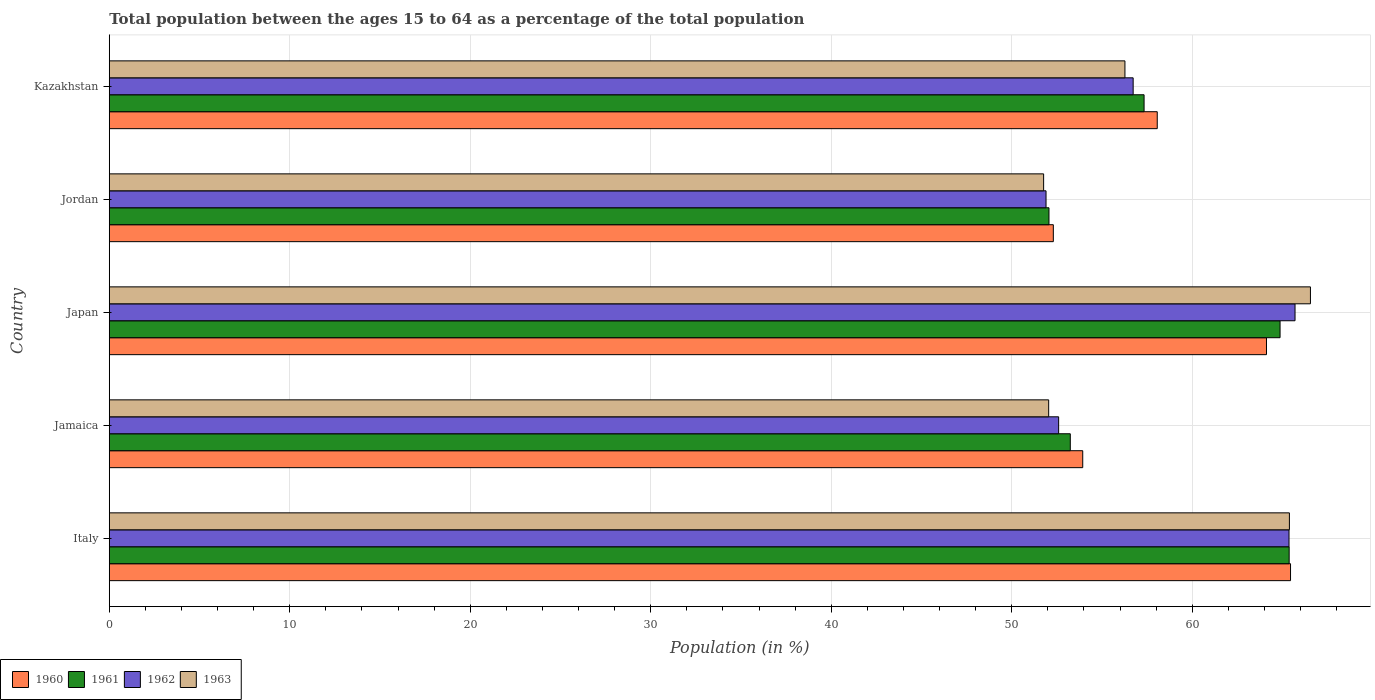Are the number of bars per tick equal to the number of legend labels?
Your answer should be very brief. Yes. Are the number of bars on each tick of the Y-axis equal?
Provide a succinct answer. Yes. How many bars are there on the 2nd tick from the top?
Keep it short and to the point. 4. What is the label of the 4th group of bars from the top?
Offer a terse response. Jamaica. In how many cases, is the number of bars for a given country not equal to the number of legend labels?
Provide a succinct answer. 0. What is the percentage of the population ages 15 to 64 in 1961 in Italy?
Keep it short and to the point. 65.37. Across all countries, what is the maximum percentage of the population ages 15 to 64 in 1963?
Your answer should be very brief. 66.55. Across all countries, what is the minimum percentage of the population ages 15 to 64 in 1962?
Keep it short and to the point. 51.9. In which country was the percentage of the population ages 15 to 64 in 1963 maximum?
Ensure brevity in your answer.  Japan. In which country was the percentage of the population ages 15 to 64 in 1961 minimum?
Your answer should be very brief. Jordan. What is the total percentage of the population ages 15 to 64 in 1962 in the graph?
Your answer should be compact. 292.29. What is the difference between the percentage of the population ages 15 to 64 in 1962 in Japan and that in Jordan?
Make the answer very short. 13.8. What is the difference between the percentage of the population ages 15 to 64 in 1961 in Jordan and the percentage of the population ages 15 to 64 in 1960 in Italy?
Offer a terse response. -13.38. What is the average percentage of the population ages 15 to 64 in 1963 per country?
Offer a very short reply. 58.4. What is the difference between the percentage of the population ages 15 to 64 in 1960 and percentage of the population ages 15 to 64 in 1963 in Japan?
Offer a very short reply. -2.43. In how many countries, is the percentage of the population ages 15 to 64 in 1962 greater than 8 ?
Provide a succinct answer. 5. What is the ratio of the percentage of the population ages 15 to 64 in 1961 in Jamaica to that in Jordan?
Your answer should be very brief. 1.02. What is the difference between the highest and the second highest percentage of the population ages 15 to 64 in 1963?
Keep it short and to the point. 1.17. What is the difference between the highest and the lowest percentage of the population ages 15 to 64 in 1963?
Provide a short and direct response. 14.78. In how many countries, is the percentage of the population ages 15 to 64 in 1963 greater than the average percentage of the population ages 15 to 64 in 1963 taken over all countries?
Give a very brief answer. 2. Is the sum of the percentage of the population ages 15 to 64 in 1962 in Italy and Jamaica greater than the maximum percentage of the population ages 15 to 64 in 1961 across all countries?
Provide a short and direct response. Yes. Is it the case that in every country, the sum of the percentage of the population ages 15 to 64 in 1961 and percentage of the population ages 15 to 64 in 1962 is greater than the percentage of the population ages 15 to 64 in 1963?
Offer a terse response. Yes. Are all the bars in the graph horizontal?
Your answer should be very brief. Yes. How many countries are there in the graph?
Keep it short and to the point. 5. What is the difference between two consecutive major ticks on the X-axis?
Give a very brief answer. 10. Does the graph contain any zero values?
Make the answer very short. No. How many legend labels are there?
Offer a very short reply. 4. How are the legend labels stacked?
Give a very brief answer. Horizontal. What is the title of the graph?
Keep it short and to the point. Total population between the ages 15 to 64 as a percentage of the total population. Does "1984" appear as one of the legend labels in the graph?
Your answer should be compact. No. What is the label or title of the Y-axis?
Give a very brief answer. Country. What is the Population (in %) of 1960 in Italy?
Ensure brevity in your answer.  65.45. What is the Population (in %) in 1961 in Italy?
Your answer should be compact. 65.37. What is the Population (in %) of 1962 in Italy?
Make the answer very short. 65.36. What is the Population (in %) in 1963 in Italy?
Provide a short and direct response. 65.38. What is the Population (in %) of 1960 in Jamaica?
Provide a short and direct response. 53.93. What is the Population (in %) of 1961 in Jamaica?
Provide a succinct answer. 53.25. What is the Population (in %) in 1962 in Jamaica?
Your answer should be compact. 52.6. What is the Population (in %) in 1963 in Jamaica?
Provide a succinct answer. 52.05. What is the Population (in %) in 1960 in Japan?
Your answer should be compact. 64.11. What is the Population (in %) in 1961 in Japan?
Your answer should be compact. 64.87. What is the Population (in %) in 1962 in Japan?
Your answer should be compact. 65.7. What is the Population (in %) of 1963 in Japan?
Provide a short and direct response. 66.55. What is the Population (in %) of 1960 in Jordan?
Your answer should be very brief. 52.31. What is the Population (in %) of 1961 in Jordan?
Your answer should be compact. 52.06. What is the Population (in %) in 1962 in Jordan?
Give a very brief answer. 51.9. What is the Population (in %) in 1963 in Jordan?
Your answer should be compact. 51.77. What is the Population (in %) of 1960 in Kazakhstan?
Your answer should be compact. 58.06. What is the Population (in %) of 1961 in Kazakhstan?
Ensure brevity in your answer.  57.33. What is the Population (in %) in 1962 in Kazakhstan?
Provide a succinct answer. 56.73. What is the Population (in %) of 1963 in Kazakhstan?
Provide a succinct answer. 56.27. Across all countries, what is the maximum Population (in %) of 1960?
Make the answer very short. 65.45. Across all countries, what is the maximum Population (in %) of 1961?
Provide a succinct answer. 65.37. Across all countries, what is the maximum Population (in %) in 1962?
Offer a very short reply. 65.7. Across all countries, what is the maximum Population (in %) of 1963?
Offer a very short reply. 66.55. Across all countries, what is the minimum Population (in %) of 1960?
Keep it short and to the point. 52.31. Across all countries, what is the minimum Population (in %) of 1961?
Your answer should be very brief. 52.06. Across all countries, what is the minimum Population (in %) of 1962?
Make the answer very short. 51.9. Across all countries, what is the minimum Population (in %) in 1963?
Ensure brevity in your answer.  51.77. What is the total Population (in %) in 1960 in the graph?
Make the answer very short. 293.86. What is the total Population (in %) in 1961 in the graph?
Ensure brevity in your answer.  292.88. What is the total Population (in %) of 1962 in the graph?
Ensure brevity in your answer.  292.29. What is the total Population (in %) in 1963 in the graph?
Provide a succinct answer. 292.02. What is the difference between the Population (in %) of 1960 in Italy and that in Jamaica?
Your answer should be very brief. 11.51. What is the difference between the Population (in %) in 1961 in Italy and that in Jamaica?
Give a very brief answer. 12.13. What is the difference between the Population (in %) of 1962 in Italy and that in Jamaica?
Your response must be concise. 12.76. What is the difference between the Population (in %) in 1963 in Italy and that in Jamaica?
Your answer should be compact. 13.34. What is the difference between the Population (in %) of 1960 in Italy and that in Japan?
Your response must be concise. 1.33. What is the difference between the Population (in %) of 1961 in Italy and that in Japan?
Your answer should be very brief. 0.5. What is the difference between the Population (in %) of 1962 in Italy and that in Japan?
Your answer should be very brief. -0.33. What is the difference between the Population (in %) in 1963 in Italy and that in Japan?
Give a very brief answer. -1.17. What is the difference between the Population (in %) in 1960 in Italy and that in Jordan?
Your answer should be compact. 13.14. What is the difference between the Population (in %) in 1961 in Italy and that in Jordan?
Offer a terse response. 13.31. What is the difference between the Population (in %) in 1962 in Italy and that in Jordan?
Your answer should be compact. 13.46. What is the difference between the Population (in %) of 1963 in Italy and that in Jordan?
Your answer should be very brief. 13.62. What is the difference between the Population (in %) of 1960 in Italy and that in Kazakhstan?
Your answer should be compact. 7.38. What is the difference between the Population (in %) in 1961 in Italy and that in Kazakhstan?
Your answer should be very brief. 8.04. What is the difference between the Population (in %) of 1962 in Italy and that in Kazakhstan?
Give a very brief answer. 8.64. What is the difference between the Population (in %) of 1963 in Italy and that in Kazakhstan?
Ensure brevity in your answer.  9.11. What is the difference between the Population (in %) of 1960 in Jamaica and that in Japan?
Make the answer very short. -10.18. What is the difference between the Population (in %) of 1961 in Jamaica and that in Japan?
Keep it short and to the point. -11.62. What is the difference between the Population (in %) of 1962 in Jamaica and that in Japan?
Provide a succinct answer. -13.1. What is the difference between the Population (in %) of 1963 in Jamaica and that in Japan?
Your response must be concise. -14.5. What is the difference between the Population (in %) in 1960 in Jamaica and that in Jordan?
Offer a very short reply. 1.63. What is the difference between the Population (in %) of 1961 in Jamaica and that in Jordan?
Provide a succinct answer. 1.18. What is the difference between the Population (in %) in 1962 in Jamaica and that in Jordan?
Your answer should be very brief. 0.7. What is the difference between the Population (in %) of 1963 in Jamaica and that in Jordan?
Provide a short and direct response. 0.28. What is the difference between the Population (in %) of 1960 in Jamaica and that in Kazakhstan?
Keep it short and to the point. -4.13. What is the difference between the Population (in %) of 1961 in Jamaica and that in Kazakhstan?
Your response must be concise. -4.09. What is the difference between the Population (in %) in 1962 in Jamaica and that in Kazakhstan?
Your answer should be compact. -4.13. What is the difference between the Population (in %) in 1963 in Jamaica and that in Kazakhstan?
Make the answer very short. -4.23. What is the difference between the Population (in %) of 1960 in Japan and that in Jordan?
Make the answer very short. 11.81. What is the difference between the Population (in %) in 1961 in Japan and that in Jordan?
Provide a short and direct response. 12.8. What is the difference between the Population (in %) in 1962 in Japan and that in Jordan?
Offer a terse response. 13.8. What is the difference between the Population (in %) in 1963 in Japan and that in Jordan?
Ensure brevity in your answer.  14.78. What is the difference between the Population (in %) in 1960 in Japan and that in Kazakhstan?
Offer a very short reply. 6.05. What is the difference between the Population (in %) of 1961 in Japan and that in Kazakhstan?
Your answer should be compact. 7.53. What is the difference between the Population (in %) of 1962 in Japan and that in Kazakhstan?
Keep it short and to the point. 8.97. What is the difference between the Population (in %) in 1963 in Japan and that in Kazakhstan?
Ensure brevity in your answer.  10.28. What is the difference between the Population (in %) of 1960 in Jordan and that in Kazakhstan?
Make the answer very short. -5.76. What is the difference between the Population (in %) of 1961 in Jordan and that in Kazakhstan?
Ensure brevity in your answer.  -5.27. What is the difference between the Population (in %) of 1962 in Jordan and that in Kazakhstan?
Offer a terse response. -4.83. What is the difference between the Population (in %) of 1963 in Jordan and that in Kazakhstan?
Your answer should be compact. -4.51. What is the difference between the Population (in %) of 1960 in Italy and the Population (in %) of 1961 in Jamaica?
Give a very brief answer. 12.2. What is the difference between the Population (in %) in 1960 in Italy and the Population (in %) in 1962 in Jamaica?
Ensure brevity in your answer.  12.85. What is the difference between the Population (in %) of 1960 in Italy and the Population (in %) of 1963 in Jamaica?
Make the answer very short. 13.4. What is the difference between the Population (in %) of 1961 in Italy and the Population (in %) of 1962 in Jamaica?
Your answer should be compact. 12.77. What is the difference between the Population (in %) in 1961 in Italy and the Population (in %) in 1963 in Jamaica?
Offer a terse response. 13.32. What is the difference between the Population (in %) of 1962 in Italy and the Population (in %) of 1963 in Jamaica?
Give a very brief answer. 13.32. What is the difference between the Population (in %) of 1960 in Italy and the Population (in %) of 1961 in Japan?
Provide a succinct answer. 0.58. What is the difference between the Population (in %) in 1960 in Italy and the Population (in %) in 1962 in Japan?
Offer a terse response. -0.25. What is the difference between the Population (in %) in 1960 in Italy and the Population (in %) in 1963 in Japan?
Your answer should be very brief. -1.1. What is the difference between the Population (in %) of 1961 in Italy and the Population (in %) of 1962 in Japan?
Offer a very short reply. -0.33. What is the difference between the Population (in %) in 1961 in Italy and the Population (in %) in 1963 in Japan?
Ensure brevity in your answer.  -1.18. What is the difference between the Population (in %) in 1962 in Italy and the Population (in %) in 1963 in Japan?
Provide a short and direct response. -1.19. What is the difference between the Population (in %) of 1960 in Italy and the Population (in %) of 1961 in Jordan?
Keep it short and to the point. 13.38. What is the difference between the Population (in %) in 1960 in Italy and the Population (in %) in 1962 in Jordan?
Keep it short and to the point. 13.55. What is the difference between the Population (in %) in 1960 in Italy and the Population (in %) in 1963 in Jordan?
Give a very brief answer. 13.68. What is the difference between the Population (in %) in 1961 in Italy and the Population (in %) in 1962 in Jordan?
Your response must be concise. 13.47. What is the difference between the Population (in %) in 1961 in Italy and the Population (in %) in 1963 in Jordan?
Keep it short and to the point. 13.6. What is the difference between the Population (in %) in 1962 in Italy and the Population (in %) in 1963 in Jordan?
Provide a short and direct response. 13.6. What is the difference between the Population (in %) of 1960 in Italy and the Population (in %) of 1961 in Kazakhstan?
Make the answer very short. 8.11. What is the difference between the Population (in %) in 1960 in Italy and the Population (in %) in 1962 in Kazakhstan?
Ensure brevity in your answer.  8.72. What is the difference between the Population (in %) of 1960 in Italy and the Population (in %) of 1963 in Kazakhstan?
Make the answer very short. 9.17. What is the difference between the Population (in %) in 1961 in Italy and the Population (in %) in 1962 in Kazakhstan?
Offer a terse response. 8.64. What is the difference between the Population (in %) of 1961 in Italy and the Population (in %) of 1963 in Kazakhstan?
Keep it short and to the point. 9.1. What is the difference between the Population (in %) in 1962 in Italy and the Population (in %) in 1963 in Kazakhstan?
Your response must be concise. 9.09. What is the difference between the Population (in %) of 1960 in Jamaica and the Population (in %) of 1961 in Japan?
Offer a terse response. -10.93. What is the difference between the Population (in %) in 1960 in Jamaica and the Population (in %) in 1962 in Japan?
Keep it short and to the point. -11.76. What is the difference between the Population (in %) of 1960 in Jamaica and the Population (in %) of 1963 in Japan?
Ensure brevity in your answer.  -12.62. What is the difference between the Population (in %) of 1961 in Jamaica and the Population (in %) of 1962 in Japan?
Provide a succinct answer. -12.45. What is the difference between the Population (in %) in 1961 in Jamaica and the Population (in %) in 1963 in Japan?
Your response must be concise. -13.3. What is the difference between the Population (in %) in 1962 in Jamaica and the Population (in %) in 1963 in Japan?
Offer a very short reply. -13.95. What is the difference between the Population (in %) in 1960 in Jamaica and the Population (in %) in 1961 in Jordan?
Provide a succinct answer. 1.87. What is the difference between the Population (in %) of 1960 in Jamaica and the Population (in %) of 1962 in Jordan?
Your response must be concise. 2.03. What is the difference between the Population (in %) in 1960 in Jamaica and the Population (in %) in 1963 in Jordan?
Provide a short and direct response. 2.17. What is the difference between the Population (in %) of 1961 in Jamaica and the Population (in %) of 1962 in Jordan?
Your answer should be very brief. 1.34. What is the difference between the Population (in %) in 1961 in Jamaica and the Population (in %) in 1963 in Jordan?
Your answer should be very brief. 1.48. What is the difference between the Population (in %) of 1962 in Jamaica and the Population (in %) of 1963 in Jordan?
Make the answer very short. 0.83. What is the difference between the Population (in %) of 1960 in Jamaica and the Population (in %) of 1961 in Kazakhstan?
Keep it short and to the point. -3.4. What is the difference between the Population (in %) in 1960 in Jamaica and the Population (in %) in 1962 in Kazakhstan?
Your response must be concise. -2.79. What is the difference between the Population (in %) of 1960 in Jamaica and the Population (in %) of 1963 in Kazakhstan?
Offer a very short reply. -2.34. What is the difference between the Population (in %) in 1961 in Jamaica and the Population (in %) in 1962 in Kazakhstan?
Your answer should be very brief. -3.48. What is the difference between the Population (in %) of 1961 in Jamaica and the Population (in %) of 1963 in Kazakhstan?
Provide a succinct answer. -3.03. What is the difference between the Population (in %) of 1962 in Jamaica and the Population (in %) of 1963 in Kazakhstan?
Ensure brevity in your answer.  -3.67. What is the difference between the Population (in %) in 1960 in Japan and the Population (in %) in 1961 in Jordan?
Make the answer very short. 12.05. What is the difference between the Population (in %) in 1960 in Japan and the Population (in %) in 1962 in Jordan?
Provide a short and direct response. 12.21. What is the difference between the Population (in %) in 1960 in Japan and the Population (in %) in 1963 in Jordan?
Your answer should be very brief. 12.35. What is the difference between the Population (in %) of 1961 in Japan and the Population (in %) of 1962 in Jordan?
Your answer should be compact. 12.97. What is the difference between the Population (in %) in 1961 in Japan and the Population (in %) in 1963 in Jordan?
Your answer should be very brief. 13.1. What is the difference between the Population (in %) in 1962 in Japan and the Population (in %) in 1963 in Jordan?
Keep it short and to the point. 13.93. What is the difference between the Population (in %) of 1960 in Japan and the Population (in %) of 1961 in Kazakhstan?
Offer a very short reply. 6.78. What is the difference between the Population (in %) of 1960 in Japan and the Population (in %) of 1962 in Kazakhstan?
Provide a succinct answer. 7.39. What is the difference between the Population (in %) of 1960 in Japan and the Population (in %) of 1963 in Kazakhstan?
Keep it short and to the point. 7.84. What is the difference between the Population (in %) of 1961 in Japan and the Population (in %) of 1962 in Kazakhstan?
Your response must be concise. 8.14. What is the difference between the Population (in %) of 1961 in Japan and the Population (in %) of 1963 in Kazakhstan?
Offer a terse response. 8.59. What is the difference between the Population (in %) of 1962 in Japan and the Population (in %) of 1963 in Kazakhstan?
Offer a very short reply. 9.42. What is the difference between the Population (in %) in 1960 in Jordan and the Population (in %) in 1961 in Kazakhstan?
Offer a very short reply. -5.03. What is the difference between the Population (in %) of 1960 in Jordan and the Population (in %) of 1962 in Kazakhstan?
Ensure brevity in your answer.  -4.42. What is the difference between the Population (in %) of 1960 in Jordan and the Population (in %) of 1963 in Kazakhstan?
Offer a terse response. -3.97. What is the difference between the Population (in %) in 1961 in Jordan and the Population (in %) in 1962 in Kazakhstan?
Provide a short and direct response. -4.66. What is the difference between the Population (in %) of 1961 in Jordan and the Population (in %) of 1963 in Kazakhstan?
Ensure brevity in your answer.  -4.21. What is the difference between the Population (in %) in 1962 in Jordan and the Population (in %) in 1963 in Kazakhstan?
Provide a succinct answer. -4.37. What is the average Population (in %) in 1960 per country?
Your answer should be very brief. 58.77. What is the average Population (in %) of 1961 per country?
Offer a terse response. 58.58. What is the average Population (in %) of 1962 per country?
Your answer should be very brief. 58.46. What is the average Population (in %) in 1963 per country?
Provide a succinct answer. 58.4. What is the difference between the Population (in %) in 1960 and Population (in %) in 1961 in Italy?
Offer a very short reply. 0.08. What is the difference between the Population (in %) of 1960 and Population (in %) of 1962 in Italy?
Keep it short and to the point. 0.08. What is the difference between the Population (in %) of 1960 and Population (in %) of 1963 in Italy?
Offer a terse response. 0.06. What is the difference between the Population (in %) in 1961 and Population (in %) in 1962 in Italy?
Make the answer very short. 0.01. What is the difference between the Population (in %) of 1961 and Population (in %) of 1963 in Italy?
Offer a terse response. -0.01. What is the difference between the Population (in %) in 1962 and Population (in %) in 1963 in Italy?
Your response must be concise. -0.02. What is the difference between the Population (in %) of 1960 and Population (in %) of 1961 in Jamaica?
Your answer should be compact. 0.69. What is the difference between the Population (in %) in 1960 and Population (in %) in 1962 in Jamaica?
Your answer should be very brief. 1.33. What is the difference between the Population (in %) of 1960 and Population (in %) of 1963 in Jamaica?
Give a very brief answer. 1.89. What is the difference between the Population (in %) in 1961 and Population (in %) in 1962 in Jamaica?
Make the answer very short. 0.65. What is the difference between the Population (in %) in 1961 and Population (in %) in 1963 in Jamaica?
Ensure brevity in your answer.  1.2. What is the difference between the Population (in %) in 1962 and Population (in %) in 1963 in Jamaica?
Make the answer very short. 0.55. What is the difference between the Population (in %) of 1960 and Population (in %) of 1961 in Japan?
Provide a succinct answer. -0.75. What is the difference between the Population (in %) of 1960 and Population (in %) of 1962 in Japan?
Keep it short and to the point. -1.58. What is the difference between the Population (in %) of 1960 and Population (in %) of 1963 in Japan?
Your response must be concise. -2.43. What is the difference between the Population (in %) in 1961 and Population (in %) in 1962 in Japan?
Offer a very short reply. -0.83. What is the difference between the Population (in %) of 1961 and Population (in %) of 1963 in Japan?
Offer a very short reply. -1.68. What is the difference between the Population (in %) in 1962 and Population (in %) in 1963 in Japan?
Make the answer very short. -0.85. What is the difference between the Population (in %) in 1960 and Population (in %) in 1961 in Jordan?
Provide a short and direct response. 0.24. What is the difference between the Population (in %) of 1960 and Population (in %) of 1962 in Jordan?
Offer a very short reply. 0.4. What is the difference between the Population (in %) of 1960 and Population (in %) of 1963 in Jordan?
Offer a terse response. 0.54. What is the difference between the Population (in %) of 1961 and Population (in %) of 1962 in Jordan?
Your answer should be compact. 0.16. What is the difference between the Population (in %) of 1961 and Population (in %) of 1963 in Jordan?
Your answer should be very brief. 0.3. What is the difference between the Population (in %) in 1962 and Population (in %) in 1963 in Jordan?
Provide a short and direct response. 0.13. What is the difference between the Population (in %) in 1960 and Population (in %) in 1961 in Kazakhstan?
Provide a succinct answer. 0.73. What is the difference between the Population (in %) of 1960 and Population (in %) of 1962 in Kazakhstan?
Provide a succinct answer. 1.34. What is the difference between the Population (in %) in 1960 and Population (in %) in 1963 in Kazakhstan?
Your answer should be compact. 1.79. What is the difference between the Population (in %) in 1961 and Population (in %) in 1962 in Kazakhstan?
Your answer should be very brief. 0.61. What is the difference between the Population (in %) in 1961 and Population (in %) in 1963 in Kazakhstan?
Give a very brief answer. 1.06. What is the difference between the Population (in %) in 1962 and Population (in %) in 1963 in Kazakhstan?
Ensure brevity in your answer.  0.46. What is the ratio of the Population (in %) in 1960 in Italy to that in Jamaica?
Offer a terse response. 1.21. What is the ratio of the Population (in %) in 1961 in Italy to that in Jamaica?
Your answer should be very brief. 1.23. What is the ratio of the Population (in %) of 1962 in Italy to that in Jamaica?
Offer a terse response. 1.24. What is the ratio of the Population (in %) of 1963 in Italy to that in Jamaica?
Keep it short and to the point. 1.26. What is the ratio of the Population (in %) in 1960 in Italy to that in Japan?
Your answer should be very brief. 1.02. What is the ratio of the Population (in %) of 1961 in Italy to that in Japan?
Provide a succinct answer. 1.01. What is the ratio of the Population (in %) in 1962 in Italy to that in Japan?
Make the answer very short. 0.99. What is the ratio of the Population (in %) in 1963 in Italy to that in Japan?
Make the answer very short. 0.98. What is the ratio of the Population (in %) of 1960 in Italy to that in Jordan?
Provide a short and direct response. 1.25. What is the ratio of the Population (in %) of 1961 in Italy to that in Jordan?
Ensure brevity in your answer.  1.26. What is the ratio of the Population (in %) in 1962 in Italy to that in Jordan?
Ensure brevity in your answer.  1.26. What is the ratio of the Population (in %) in 1963 in Italy to that in Jordan?
Your response must be concise. 1.26. What is the ratio of the Population (in %) of 1960 in Italy to that in Kazakhstan?
Make the answer very short. 1.13. What is the ratio of the Population (in %) in 1961 in Italy to that in Kazakhstan?
Your answer should be compact. 1.14. What is the ratio of the Population (in %) of 1962 in Italy to that in Kazakhstan?
Offer a very short reply. 1.15. What is the ratio of the Population (in %) of 1963 in Italy to that in Kazakhstan?
Ensure brevity in your answer.  1.16. What is the ratio of the Population (in %) in 1960 in Jamaica to that in Japan?
Keep it short and to the point. 0.84. What is the ratio of the Population (in %) of 1961 in Jamaica to that in Japan?
Give a very brief answer. 0.82. What is the ratio of the Population (in %) in 1962 in Jamaica to that in Japan?
Your response must be concise. 0.8. What is the ratio of the Population (in %) in 1963 in Jamaica to that in Japan?
Offer a very short reply. 0.78. What is the ratio of the Population (in %) in 1960 in Jamaica to that in Jordan?
Provide a succinct answer. 1.03. What is the ratio of the Population (in %) of 1961 in Jamaica to that in Jordan?
Ensure brevity in your answer.  1.02. What is the ratio of the Population (in %) of 1962 in Jamaica to that in Jordan?
Your answer should be very brief. 1.01. What is the ratio of the Population (in %) of 1963 in Jamaica to that in Jordan?
Offer a terse response. 1.01. What is the ratio of the Population (in %) of 1960 in Jamaica to that in Kazakhstan?
Provide a succinct answer. 0.93. What is the ratio of the Population (in %) of 1961 in Jamaica to that in Kazakhstan?
Ensure brevity in your answer.  0.93. What is the ratio of the Population (in %) of 1962 in Jamaica to that in Kazakhstan?
Keep it short and to the point. 0.93. What is the ratio of the Population (in %) of 1963 in Jamaica to that in Kazakhstan?
Make the answer very short. 0.92. What is the ratio of the Population (in %) of 1960 in Japan to that in Jordan?
Make the answer very short. 1.23. What is the ratio of the Population (in %) in 1961 in Japan to that in Jordan?
Offer a very short reply. 1.25. What is the ratio of the Population (in %) of 1962 in Japan to that in Jordan?
Ensure brevity in your answer.  1.27. What is the ratio of the Population (in %) of 1963 in Japan to that in Jordan?
Your answer should be compact. 1.29. What is the ratio of the Population (in %) of 1960 in Japan to that in Kazakhstan?
Give a very brief answer. 1.1. What is the ratio of the Population (in %) of 1961 in Japan to that in Kazakhstan?
Your answer should be compact. 1.13. What is the ratio of the Population (in %) of 1962 in Japan to that in Kazakhstan?
Give a very brief answer. 1.16. What is the ratio of the Population (in %) of 1963 in Japan to that in Kazakhstan?
Give a very brief answer. 1.18. What is the ratio of the Population (in %) of 1960 in Jordan to that in Kazakhstan?
Your answer should be very brief. 0.9. What is the ratio of the Population (in %) in 1961 in Jordan to that in Kazakhstan?
Offer a terse response. 0.91. What is the ratio of the Population (in %) in 1962 in Jordan to that in Kazakhstan?
Provide a short and direct response. 0.91. What is the ratio of the Population (in %) in 1963 in Jordan to that in Kazakhstan?
Provide a short and direct response. 0.92. What is the difference between the highest and the second highest Population (in %) in 1960?
Provide a succinct answer. 1.33. What is the difference between the highest and the second highest Population (in %) in 1961?
Give a very brief answer. 0.5. What is the difference between the highest and the second highest Population (in %) in 1962?
Provide a succinct answer. 0.33. What is the difference between the highest and the second highest Population (in %) in 1963?
Keep it short and to the point. 1.17. What is the difference between the highest and the lowest Population (in %) in 1960?
Keep it short and to the point. 13.14. What is the difference between the highest and the lowest Population (in %) in 1961?
Provide a succinct answer. 13.31. What is the difference between the highest and the lowest Population (in %) of 1962?
Offer a terse response. 13.8. What is the difference between the highest and the lowest Population (in %) in 1963?
Your answer should be very brief. 14.78. 